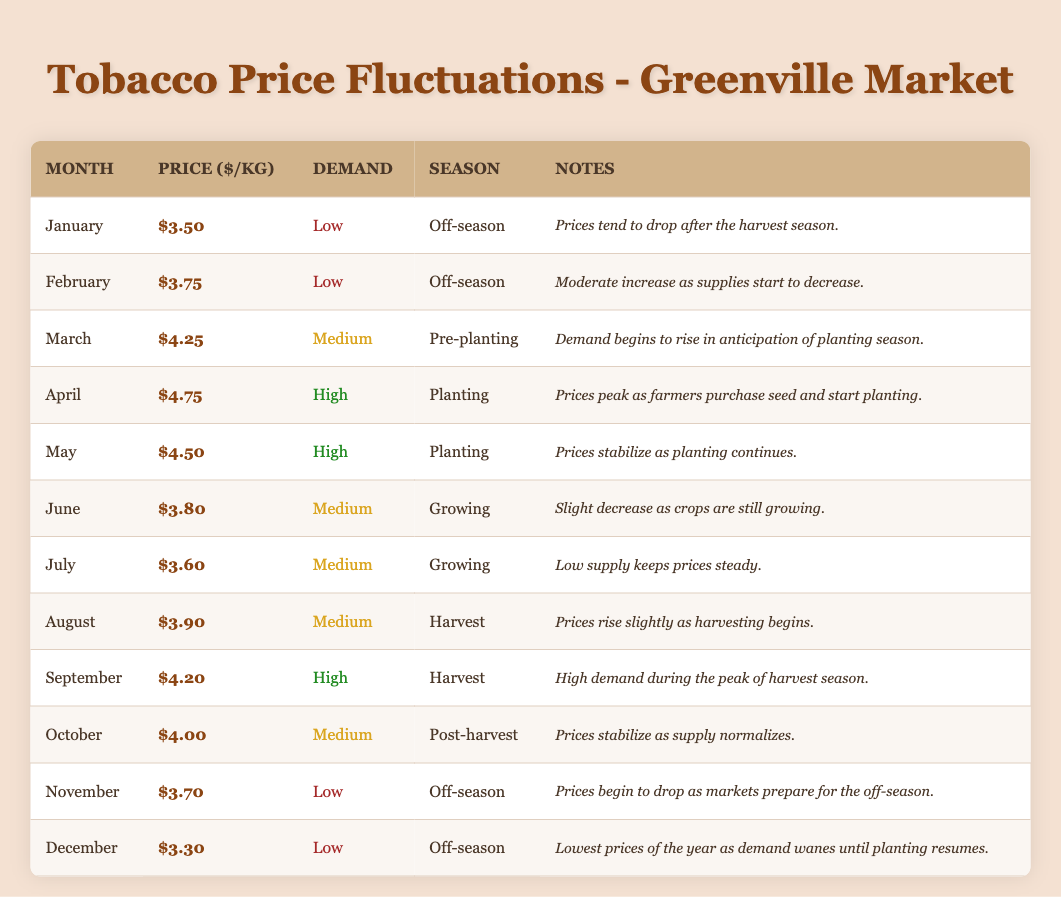What was the highest price per kilogram of tobacco in January? The highest price in January was $3.50. It corresponds to the only entry for January in the table.
Answer: 3.50 What demand level was recorded in September? The demand level recorded in September was High. This is found directly in the table under the demand column for September.
Answer: High What month had the lowest demand level, and what was the price per kilogram during that month? The lowest demand level was recorded in December, with a price of $3.30 per kilogram. This can be found by checking both the demand and price columns for December.
Answer: December, 3.30 Which month has the highest average price per kilogram between April and August? The average price from April to August is calculated by summing the prices ($4.75 + $4.50 + $3.90) and dividing by the number of months (3). The total is $13.15; thus, the average price is $4.38 for this period, making April the highest month at $4.75.
Answer: April, 4.75 Is it true that the demand level was Medium for the month of June? Yes, it is true. By looking at the demand column for June, we see the level is listed as Medium.
Answer: Yes What was the range of prices from January to December? To find the range, subtract the lowest price in December ($3.30) from the highest price in April ($4.75): $4.75 - $3.30 = $1.45. The range of prices from January to December is thus $1.45.
Answer: 1.45 How many months in total had a price greater than $4.00? The months with prices greater than $4.00 are April ($4.75), May ($4.50), March ($4.25), September ($4.20), and October ($4.00), totaling 4 months since October is not exceeding $4.00.
Answer: 4 What was the trend in prices from January to February? The price increased from $3.50 in January to $3.75 in February, showing a trend of increase. This is seen by comparing the price column for the two months.
Answer: Increase During which months did the price per kilogram drop compared to the previous month? The months where prices dropped are June ($3.80) following May ($4.50), July ($3.60) after June ($3.80), and November ($3.70) after October ($4.00). This requires checking each month's price against the previous one.
Answer: June, July, November 